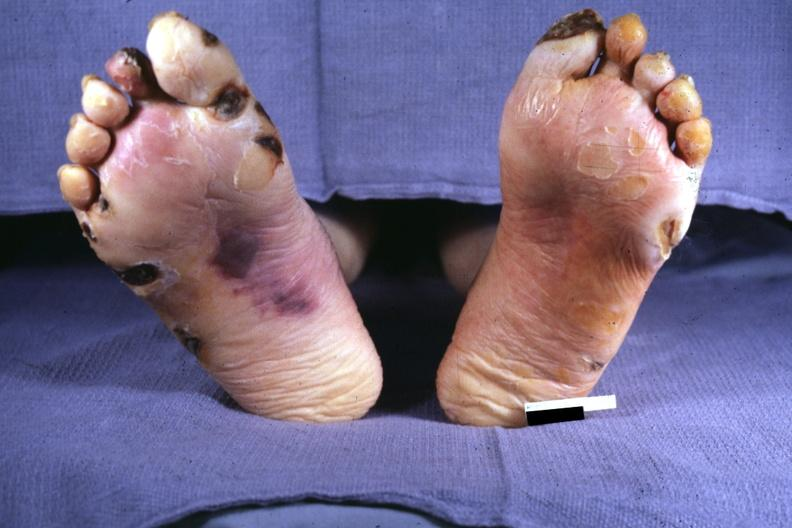what does this image show?
Answer the question using a single word or phrase. Typical gangrene 